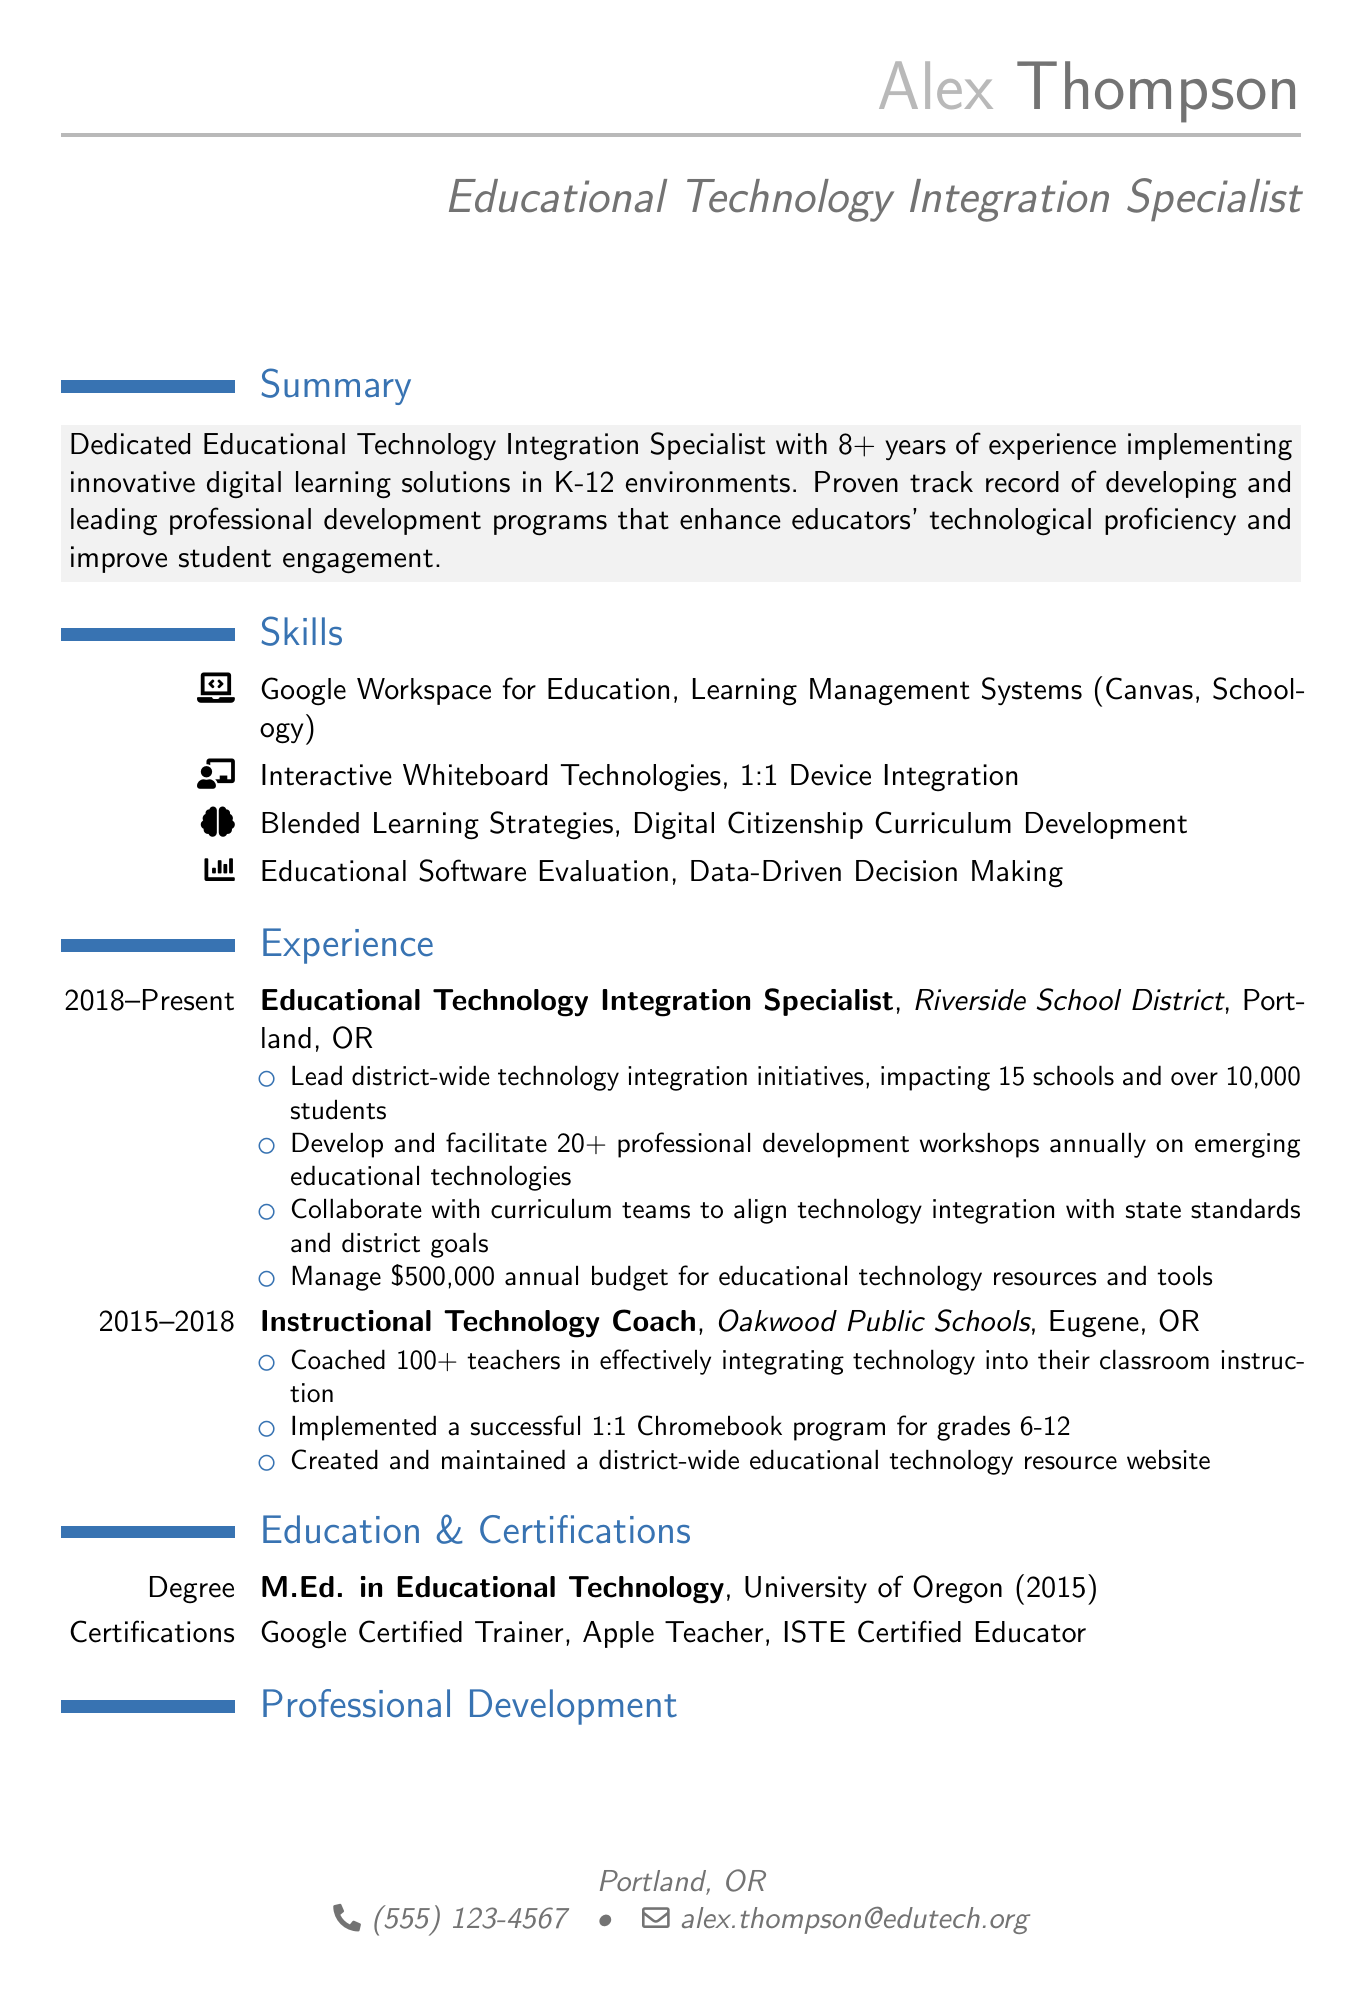What is the name of the individual? The name of the individual is listed at the top of the resume under personal information.
Answer: Alex Thompson What is the highest degree attained by Alex? The highest degree is found in the education section of the resume.
Answer: M.Ed. in Educational Technology How many years of experience does Alex have? The summary section specifies the number of years of experience.
Answer: 8+ years What is the annual budget Alex manages for educational technology? The corresponding responsibility in the experience section indicates the amount.
Answer: $500,000 What award did Alex receive from the Oregon Department of Education? The achievements section lists the award.
Answer: Innovative Technology Educator Award How many professional development workshops does Alex facilitate annually? The experience section mentions this figure alongside responsibilities.
Answer: 20+ Which school district does Alex currently work in? The experience section shows the names of the organizations where Alex has worked.
Answer: Riverside School District What certification does Alex hold related to Google? The certifications section provides this information.
Answer: Google Certified Trainer Name one program that Alex led for professional development. The professional development section lists the programs led by Alex.
Answer: 21st Century Classroom Technologies Workshop Series 